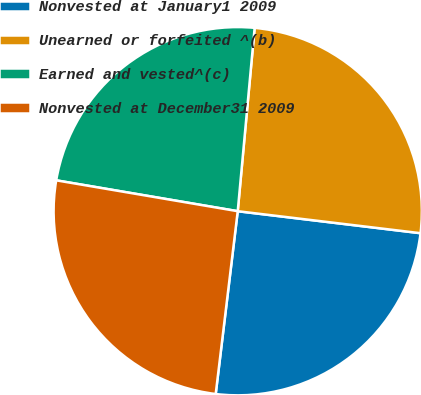Convert chart. <chart><loc_0><loc_0><loc_500><loc_500><pie_chart><fcel>Nonvested at January1 2009<fcel>Unearned or forfeited ^(b)<fcel>Earned and vested^(c)<fcel>Nonvested at December31 2009<nl><fcel>25.0%<fcel>25.44%<fcel>23.78%<fcel>25.77%<nl></chart> 